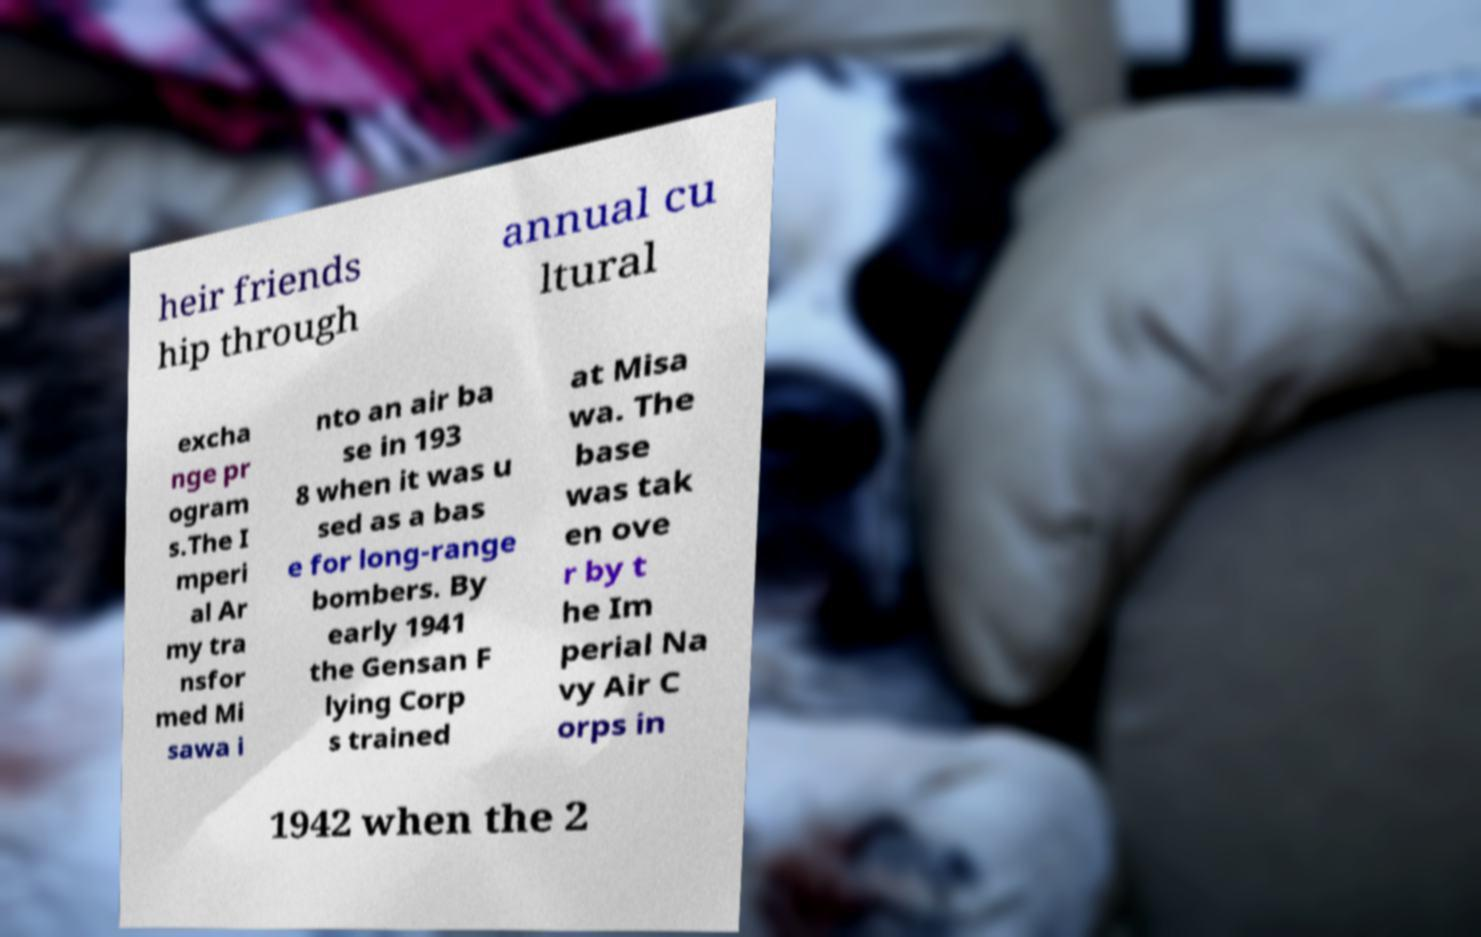There's text embedded in this image that I need extracted. Can you transcribe it verbatim? heir friends hip through annual cu ltural excha nge pr ogram s.The I mperi al Ar my tra nsfor med Mi sawa i nto an air ba se in 193 8 when it was u sed as a bas e for long-range bombers. By early 1941 the Gensan F lying Corp s trained at Misa wa. The base was tak en ove r by t he Im perial Na vy Air C orps in 1942 when the 2 